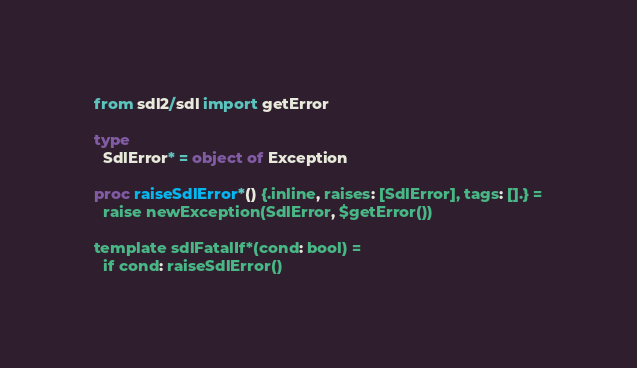<code> <loc_0><loc_0><loc_500><loc_500><_Nim_>from sdl2/sdl import getError

type
  SdlError* = object of Exception

proc raiseSdlError*() {.inline, raises: [SdlError], tags: [].} =
  raise newException(SdlError, $getError())

template sdlFatalIf*(cond: bool) =
  if cond: raiseSdlError()
</code> 